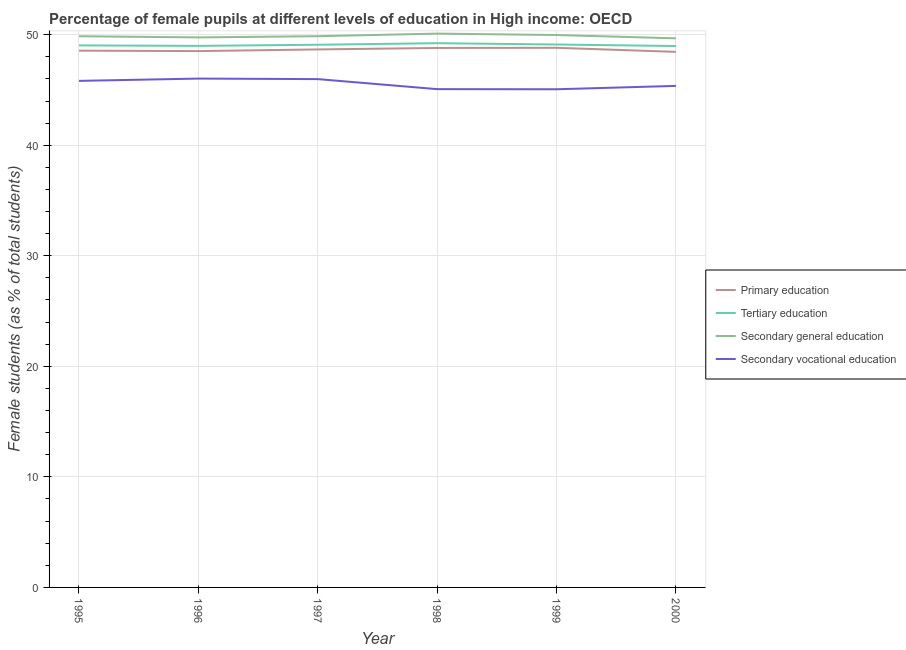How many different coloured lines are there?
Provide a succinct answer. 4. What is the percentage of female students in secondary vocational education in 1997?
Give a very brief answer. 45.98. Across all years, what is the maximum percentage of female students in secondary vocational education?
Provide a short and direct response. 46.03. Across all years, what is the minimum percentage of female students in tertiary education?
Your answer should be compact. 48.97. In which year was the percentage of female students in secondary education minimum?
Your answer should be very brief. 2000. What is the total percentage of female students in primary education in the graph?
Provide a short and direct response. 291.79. What is the difference between the percentage of female students in primary education in 1997 and that in 1999?
Your answer should be very brief. -0.15. What is the difference between the percentage of female students in secondary education in 2000 and the percentage of female students in primary education in 1999?
Ensure brevity in your answer.  0.86. What is the average percentage of female students in primary education per year?
Provide a short and direct response. 48.63. In the year 1995, what is the difference between the percentage of female students in primary education and percentage of female students in tertiary education?
Keep it short and to the point. -0.48. What is the ratio of the percentage of female students in primary education in 1998 to that in 2000?
Offer a very short reply. 1.01. Is the difference between the percentage of female students in tertiary education in 1996 and 1998 greater than the difference between the percentage of female students in secondary vocational education in 1996 and 1998?
Your answer should be very brief. No. What is the difference between the highest and the second highest percentage of female students in tertiary education?
Offer a very short reply. 0.12. What is the difference between the highest and the lowest percentage of female students in secondary vocational education?
Provide a succinct answer. 0.97. In how many years, is the percentage of female students in secondary vocational education greater than the average percentage of female students in secondary vocational education taken over all years?
Make the answer very short. 3. Is it the case that in every year, the sum of the percentage of female students in tertiary education and percentage of female students in primary education is greater than the sum of percentage of female students in secondary vocational education and percentage of female students in secondary education?
Offer a very short reply. Yes. Is it the case that in every year, the sum of the percentage of female students in primary education and percentage of female students in tertiary education is greater than the percentage of female students in secondary education?
Ensure brevity in your answer.  Yes. Is the percentage of female students in tertiary education strictly greater than the percentage of female students in secondary vocational education over the years?
Your answer should be very brief. Yes. Is the percentage of female students in secondary vocational education strictly less than the percentage of female students in primary education over the years?
Your response must be concise. Yes. How many lines are there?
Make the answer very short. 4. Does the graph contain any zero values?
Provide a succinct answer. No. Where does the legend appear in the graph?
Ensure brevity in your answer.  Center right. How many legend labels are there?
Offer a terse response. 4. What is the title of the graph?
Your response must be concise. Percentage of female pupils at different levels of education in High income: OECD. Does "Forest" appear as one of the legend labels in the graph?
Offer a very short reply. No. What is the label or title of the X-axis?
Make the answer very short. Year. What is the label or title of the Y-axis?
Your response must be concise. Female students (as % of total students). What is the Female students (as % of total students) of Primary education in 1995?
Ensure brevity in your answer.  48.55. What is the Female students (as % of total students) of Tertiary education in 1995?
Offer a terse response. 49.03. What is the Female students (as % of total students) of Secondary general education in 1995?
Give a very brief answer. 49.86. What is the Female students (as % of total students) of Secondary vocational education in 1995?
Ensure brevity in your answer.  45.82. What is the Female students (as % of total students) of Primary education in 1996?
Provide a succinct answer. 48.52. What is the Female students (as % of total students) of Tertiary education in 1996?
Provide a short and direct response. 48.99. What is the Female students (as % of total students) in Secondary general education in 1996?
Ensure brevity in your answer.  49.75. What is the Female students (as % of total students) of Secondary vocational education in 1996?
Ensure brevity in your answer.  46.03. What is the Female students (as % of total students) of Primary education in 1997?
Give a very brief answer. 48.67. What is the Female students (as % of total students) of Tertiary education in 1997?
Your answer should be very brief. 49.09. What is the Female students (as % of total students) of Secondary general education in 1997?
Offer a terse response. 49.86. What is the Female students (as % of total students) in Secondary vocational education in 1997?
Offer a terse response. 45.98. What is the Female students (as % of total students) of Primary education in 1998?
Keep it short and to the point. 48.8. What is the Female students (as % of total students) in Tertiary education in 1998?
Make the answer very short. 49.23. What is the Female students (as % of total students) of Secondary general education in 1998?
Offer a very short reply. 50.1. What is the Female students (as % of total students) of Secondary vocational education in 1998?
Ensure brevity in your answer.  45.07. What is the Female students (as % of total students) of Primary education in 1999?
Make the answer very short. 48.81. What is the Female students (as % of total students) of Tertiary education in 1999?
Offer a terse response. 49.11. What is the Female students (as % of total students) of Secondary general education in 1999?
Give a very brief answer. 49.97. What is the Female students (as % of total students) of Secondary vocational education in 1999?
Ensure brevity in your answer.  45.06. What is the Female students (as % of total students) in Primary education in 2000?
Give a very brief answer. 48.45. What is the Female students (as % of total students) of Tertiary education in 2000?
Make the answer very short. 48.97. What is the Female students (as % of total students) in Secondary general education in 2000?
Offer a terse response. 49.67. What is the Female students (as % of total students) of Secondary vocational education in 2000?
Keep it short and to the point. 45.37. Across all years, what is the maximum Female students (as % of total students) of Primary education?
Give a very brief answer. 48.81. Across all years, what is the maximum Female students (as % of total students) of Tertiary education?
Offer a very short reply. 49.23. Across all years, what is the maximum Female students (as % of total students) in Secondary general education?
Provide a short and direct response. 50.1. Across all years, what is the maximum Female students (as % of total students) in Secondary vocational education?
Keep it short and to the point. 46.03. Across all years, what is the minimum Female students (as % of total students) in Primary education?
Your answer should be compact. 48.45. Across all years, what is the minimum Female students (as % of total students) in Tertiary education?
Provide a short and direct response. 48.97. Across all years, what is the minimum Female students (as % of total students) of Secondary general education?
Keep it short and to the point. 49.67. Across all years, what is the minimum Female students (as % of total students) of Secondary vocational education?
Offer a very short reply. 45.06. What is the total Female students (as % of total students) in Primary education in the graph?
Ensure brevity in your answer.  291.79. What is the total Female students (as % of total students) in Tertiary education in the graph?
Provide a short and direct response. 294.42. What is the total Female students (as % of total students) in Secondary general education in the graph?
Ensure brevity in your answer.  299.21. What is the total Female students (as % of total students) in Secondary vocational education in the graph?
Keep it short and to the point. 273.33. What is the difference between the Female students (as % of total students) of Primary education in 1995 and that in 1996?
Ensure brevity in your answer.  0.04. What is the difference between the Female students (as % of total students) in Tertiary education in 1995 and that in 1996?
Offer a very short reply. 0.04. What is the difference between the Female students (as % of total students) in Secondary general education in 1995 and that in 1996?
Provide a succinct answer. 0.11. What is the difference between the Female students (as % of total students) of Secondary vocational education in 1995 and that in 1996?
Your answer should be compact. -0.21. What is the difference between the Female students (as % of total students) of Primary education in 1995 and that in 1997?
Offer a terse response. -0.11. What is the difference between the Female students (as % of total students) of Tertiary education in 1995 and that in 1997?
Keep it short and to the point. -0.06. What is the difference between the Female students (as % of total students) in Secondary general education in 1995 and that in 1997?
Make the answer very short. -0. What is the difference between the Female students (as % of total students) in Secondary vocational education in 1995 and that in 1997?
Provide a short and direct response. -0.16. What is the difference between the Female students (as % of total students) of Primary education in 1995 and that in 1998?
Provide a short and direct response. -0.24. What is the difference between the Female students (as % of total students) in Tertiary education in 1995 and that in 1998?
Your answer should be very brief. -0.2. What is the difference between the Female students (as % of total students) of Secondary general education in 1995 and that in 1998?
Ensure brevity in your answer.  -0.24. What is the difference between the Female students (as % of total students) of Secondary vocational education in 1995 and that in 1998?
Provide a succinct answer. 0.75. What is the difference between the Female students (as % of total students) of Primary education in 1995 and that in 1999?
Provide a succinct answer. -0.26. What is the difference between the Female students (as % of total students) in Tertiary education in 1995 and that in 1999?
Make the answer very short. -0.08. What is the difference between the Female students (as % of total students) in Secondary general education in 1995 and that in 1999?
Offer a terse response. -0.11. What is the difference between the Female students (as % of total students) of Secondary vocational education in 1995 and that in 1999?
Give a very brief answer. 0.76. What is the difference between the Female students (as % of total students) in Primary education in 1995 and that in 2000?
Your answer should be compact. 0.11. What is the difference between the Female students (as % of total students) in Tertiary education in 1995 and that in 2000?
Your answer should be very brief. 0.06. What is the difference between the Female students (as % of total students) in Secondary general education in 1995 and that in 2000?
Offer a terse response. 0.19. What is the difference between the Female students (as % of total students) in Secondary vocational education in 1995 and that in 2000?
Keep it short and to the point. 0.45. What is the difference between the Female students (as % of total students) of Primary education in 1996 and that in 1997?
Provide a short and direct response. -0.15. What is the difference between the Female students (as % of total students) of Tertiary education in 1996 and that in 1997?
Your answer should be compact. -0.1. What is the difference between the Female students (as % of total students) in Secondary general education in 1996 and that in 1997?
Give a very brief answer. -0.11. What is the difference between the Female students (as % of total students) of Secondary vocational education in 1996 and that in 1997?
Your response must be concise. 0.05. What is the difference between the Female students (as % of total students) of Primary education in 1996 and that in 1998?
Your answer should be very brief. -0.28. What is the difference between the Female students (as % of total students) in Tertiary education in 1996 and that in 1998?
Your answer should be compact. -0.24. What is the difference between the Female students (as % of total students) of Secondary general education in 1996 and that in 1998?
Offer a very short reply. -0.34. What is the difference between the Female students (as % of total students) in Secondary vocational education in 1996 and that in 1998?
Provide a succinct answer. 0.96. What is the difference between the Female students (as % of total students) in Primary education in 1996 and that in 1999?
Make the answer very short. -0.3. What is the difference between the Female students (as % of total students) in Tertiary education in 1996 and that in 1999?
Your answer should be compact. -0.12. What is the difference between the Female students (as % of total students) of Secondary general education in 1996 and that in 1999?
Ensure brevity in your answer.  -0.22. What is the difference between the Female students (as % of total students) of Secondary vocational education in 1996 and that in 1999?
Provide a short and direct response. 0.97. What is the difference between the Female students (as % of total students) in Primary education in 1996 and that in 2000?
Provide a succinct answer. 0.07. What is the difference between the Female students (as % of total students) in Tertiary education in 1996 and that in 2000?
Your answer should be compact. 0.01. What is the difference between the Female students (as % of total students) in Secondary general education in 1996 and that in 2000?
Provide a short and direct response. 0.08. What is the difference between the Female students (as % of total students) of Secondary vocational education in 1996 and that in 2000?
Give a very brief answer. 0.66. What is the difference between the Female students (as % of total students) of Primary education in 1997 and that in 1998?
Provide a short and direct response. -0.13. What is the difference between the Female students (as % of total students) of Tertiary education in 1997 and that in 1998?
Your answer should be very brief. -0.14. What is the difference between the Female students (as % of total students) of Secondary general education in 1997 and that in 1998?
Your answer should be very brief. -0.24. What is the difference between the Female students (as % of total students) of Secondary vocational education in 1997 and that in 1998?
Make the answer very short. 0.91. What is the difference between the Female students (as % of total students) in Primary education in 1997 and that in 1999?
Offer a terse response. -0.15. What is the difference between the Female students (as % of total students) in Tertiary education in 1997 and that in 1999?
Provide a short and direct response. -0.02. What is the difference between the Female students (as % of total students) in Secondary general education in 1997 and that in 1999?
Offer a terse response. -0.11. What is the difference between the Female students (as % of total students) of Secondary vocational education in 1997 and that in 1999?
Your answer should be compact. 0.92. What is the difference between the Female students (as % of total students) of Primary education in 1997 and that in 2000?
Provide a succinct answer. 0.22. What is the difference between the Female students (as % of total students) of Tertiary education in 1997 and that in 2000?
Provide a short and direct response. 0.12. What is the difference between the Female students (as % of total students) in Secondary general education in 1997 and that in 2000?
Your response must be concise. 0.19. What is the difference between the Female students (as % of total students) of Secondary vocational education in 1997 and that in 2000?
Give a very brief answer. 0.61. What is the difference between the Female students (as % of total students) of Primary education in 1998 and that in 1999?
Offer a terse response. -0.01. What is the difference between the Female students (as % of total students) in Tertiary education in 1998 and that in 1999?
Your response must be concise. 0.12. What is the difference between the Female students (as % of total students) of Secondary general education in 1998 and that in 1999?
Your answer should be compact. 0.13. What is the difference between the Female students (as % of total students) of Secondary vocational education in 1998 and that in 1999?
Offer a terse response. 0.01. What is the difference between the Female students (as % of total students) of Primary education in 1998 and that in 2000?
Keep it short and to the point. 0.35. What is the difference between the Female students (as % of total students) of Tertiary education in 1998 and that in 2000?
Give a very brief answer. 0.26. What is the difference between the Female students (as % of total students) in Secondary general education in 1998 and that in 2000?
Keep it short and to the point. 0.43. What is the difference between the Female students (as % of total students) in Secondary vocational education in 1998 and that in 2000?
Keep it short and to the point. -0.29. What is the difference between the Female students (as % of total students) in Primary education in 1999 and that in 2000?
Make the answer very short. 0.37. What is the difference between the Female students (as % of total students) in Tertiary education in 1999 and that in 2000?
Make the answer very short. 0.14. What is the difference between the Female students (as % of total students) of Secondary general education in 1999 and that in 2000?
Provide a succinct answer. 0.3. What is the difference between the Female students (as % of total students) of Secondary vocational education in 1999 and that in 2000?
Your answer should be very brief. -0.31. What is the difference between the Female students (as % of total students) of Primary education in 1995 and the Female students (as % of total students) of Tertiary education in 1996?
Give a very brief answer. -0.43. What is the difference between the Female students (as % of total students) in Primary education in 1995 and the Female students (as % of total students) in Secondary general education in 1996?
Your answer should be very brief. -1.2. What is the difference between the Female students (as % of total students) in Primary education in 1995 and the Female students (as % of total students) in Secondary vocational education in 1996?
Make the answer very short. 2.52. What is the difference between the Female students (as % of total students) of Tertiary education in 1995 and the Female students (as % of total students) of Secondary general education in 1996?
Keep it short and to the point. -0.72. What is the difference between the Female students (as % of total students) in Tertiary education in 1995 and the Female students (as % of total students) in Secondary vocational education in 1996?
Ensure brevity in your answer.  3. What is the difference between the Female students (as % of total students) in Secondary general education in 1995 and the Female students (as % of total students) in Secondary vocational education in 1996?
Your answer should be very brief. 3.83. What is the difference between the Female students (as % of total students) of Primary education in 1995 and the Female students (as % of total students) of Tertiary education in 1997?
Your answer should be compact. -0.54. What is the difference between the Female students (as % of total students) of Primary education in 1995 and the Female students (as % of total students) of Secondary general education in 1997?
Offer a very short reply. -1.31. What is the difference between the Female students (as % of total students) of Primary education in 1995 and the Female students (as % of total students) of Secondary vocational education in 1997?
Provide a short and direct response. 2.57. What is the difference between the Female students (as % of total students) of Tertiary education in 1995 and the Female students (as % of total students) of Secondary general education in 1997?
Your response must be concise. -0.83. What is the difference between the Female students (as % of total students) in Tertiary education in 1995 and the Female students (as % of total students) in Secondary vocational education in 1997?
Your response must be concise. 3.05. What is the difference between the Female students (as % of total students) of Secondary general education in 1995 and the Female students (as % of total students) of Secondary vocational education in 1997?
Ensure brevity in your answer.  3.88. What is the difference between the Female students (as % of total students) in Primary education in 1995 and the Female students (as % of total students) in Tertiary education in 1998?
Your answer should be compact. -0.68. What is the difference between the Female students (as % of total students) in Primary education in 1995 and the Female students (as % of total students) in Secondary general education in 1998?
Offer a very short reply. -1.54. What is the difference between the Female students (as % of total students) of Primary education in 1995 and the Female students (as % of total students) of Secondary vocational education in 1998?
Provide a succinct answer. 3.48. What is the difference between the Female students (as % of total students) of Tertiary education in 1995 and the Female students (as % of total students) of Secondary general education in 1998?
Your answer should be very brief. -1.07. What is the difference between the Female students (as % of total students) in Tertiary education in 1995 and the Female students (as % of total students) in Secondary vocational education in 1998?
Give a very brief answer. 3.96. What is the difference between the Female students (as % of total students) of Secondary general education in 1995 and the Female students (as % of total students) of Secondary vocational education in 1998?
Your answer should be compact. 4.78. What is the difference between the Female students (as % of total students) of Primary education in 1995 and the Female students (as % of total students) of Tertiary education in 1999?
Ensure brevity in your answer.  -0.56. What is the difference between the Female students (as % of total students) of Primary education in 1995 and the Female students (as % of total students) of Secondary general education in 1999?
Ensure brevity in your answer.  -1.41. What is the difference between the Female students (as % of total students) in Primary education in 1995 and the Female students (as % of total students) in Secondary vocational education in 1999?
Make the answer very short. 3.49. What is the difference between the Female students (as % of total students) of Tertiary education in 1995 and the Female students (as % of total students) of Secondary general education in 1999?
Keep it short and to the point. -0.94. What is the difference between the Female students (as % of total students) of Tertiary education in 1995 and the Female students (as % of total students) of Secondary vocational education in 1999?
Make the answer very short. 3.97. What is the difference between the Female students (as % of total students) of Secondary general education in 1995 and the Female students (as % of total students) of Secondary vocational education in 1999?
Keep it short and to the point. 4.8. What is the difference between the Female students (as % of total students) in Primary education in 1995 and the Female students (as % of total students) in Tertiary education in 2000?
Your answer should be compact. -0.42. What is the difference between the Female students (as % of total students) of Primary education in 1995 and the Female students (as % of total students) of Secondary general education in 2000?
Ensure brevity in your answer.  -1.12. What is the difference between the Female students (as % of total students) of Primary education in 1995 and the Female students (as % of total students) of Secondary vocational education in 2000?
Provide a short and direct response. 3.19. What is the difference between the Female students (as % of total students) in Tertiary education in 1995 and the Female students (as % of total students) in Secondary general education in 2000?
Give a very brief answer. -0.64. What is the difference between the Female students (as % of total students) in Tertiary education in 1995 and the Female students (as % of total students) in Secondary vocational education in 2000?
Keep it short and to the point. 3.66. What is the difference between the Female students (as % of total students) of Secondary general education in 1995 and the Female students (as % of total students) of Secondary vocational education in 2000?
Provide a succinct answer. 4.49. What is the difference between the Female students (as % of total students) in Primary education in 1996 and the Female students (as % of total students) in Tertiary education in 1997?
Provide a short and direct response. -0.58. What is the difference between the Female students (as % of total students) of Primary education in 1996 and the Female students (as % of total students) of Secondary general education in 1997?
Provide a succinct answer. -1.35. What is the difference between the Female students (as % of total students) in Primary education in 1996 and the Female students (as % of total students) in Secondary vocational education in 1997?
Offer a terse response. 2.53. What is the difference between the Female students (as % of total students) of Tertiary education in 1996 and the Female students (as % of total students) of Secondary general education in 1997?
Offer a terse response. -0.87. What is the difference between the Female students (as % of total students) in Tertiary education in 1996 and the Female students (as % of total students) in Secondary vocational education in 1997?
Keep it short and to the point. 3.01. What is the difference between the Female students (as % of total students) of Secondary general education in 1996 and the Female students (as % of total students) of Secondary vocational education in 1997?
Ensure brevity in your answer.  3.77. What is the difference between the Female students (as % of total students) in Primary education in 1996 and the Female students (as % of total students) in Tertiary education in 1998?
Your answer should be very brief. -0.71. What is the difference between the Female students (as % of total students) of Primary education in 1996 and the Female students (as % of total students) of Secondary general education in 1998?
Give a very brief answer. -1.58. What is the difference between the Female students (as % of total students) in Primary education in 1996 and the Female students (as % of total students) in Secondary vocational education in 1998?
Keep it short and to the point. 3.44. What is the difference between the Female students (as % of total students) of Tertiary education in 1996 and the Female students (as % of total students) of Secondary general education in 1998?
Ensure brevity in your answer.  -1.11. What is the difference between the Female students (as % of total students) of Tertiary education in 1996 and the Female students (as % of total students) of Secondary vocational education in 1998?
Your answer should be very brief. 3.91. What is the difference between the Female students (as % of total students) of Secondary general education in 1996 and the Female students (as % of total students) of Secondary vocational education in 1998?
Provide a succinct answer. 4.68. What is the difference between the Female students (as % of total students) in Primary education in 1996 and the Female students (as % of total students) in Tertiary education in 1999?
Your response must be concise. -0.6. What is the difference between the Female students (as % of total students) of Primary education in 1996 and the Female students (as % of total students) of Secondary general education in 1999?
Provide a succinct answer. -1.45. What is the difference between the Female students (as % of total students) in Primary education in 1996 and the Female students (as % of total students) in Secondary vocational education in 1999?
Ensure brevity in your answer.  3.45. What is the difference between the Female students (as % of total students) in Tertiary education in 1996 and the Female students (as % of total students) in Secondary general education in 1999?
Ensure brevity in your answer.  -0.98. What is the difference between the Female students (as % of total students) of Tertiary education in 1996 and the Female students (as % of total students) of Secondary vocational education in 1999?
Your answer should be compact. 3.93. What is the difference between the Female students (as % of total students) of Secondary general education in 1996 and the Female students (as % of total students) of Secondary vocational education in 1999?
Your answer should be compact. 4.69. What is the difference between the Female students (as % of total students) of Primary education in 1996 and the Female students (as % of total students) of Tertiary education in 2000?
Offer a very short reply. -0.46. What is the difference between the Female students (as % of total students) in Primary education in 1996 and the Female students (as % of total students) in Secondary general education in 2000?
Your response must be concise. -1.16. What is the difference between the Female students (as % of total students) of Primary education in 1996 and the Female students (as % of total students) of Secondary vocational education in 2000?
Your answer should be compact. 3.15. What is the difference between the Female students (as % of total students) in Tertiary education in 1996 and the Female students (as % of total students) in Secondary general education in 2000?
Give a very brief answer. -0.68. What is the difference between the Female students (as % of total students) of Tertiary education in 1996 and the Female students (as % of total students) of Secondary vocational education in 2000?
Your answer should be compact. 3.62. What is the difference between the Female students (as % of total students) of Secondary general education in 1996 and the Female students (as % of total students) of Secondary vocational education in 2000?
Your answer should be very brief. 4.39. What is the difference between the Female students (as % of total students) of Primary education in 1997 and the Female students (as % of total students) of Tertiary education in 1998?
Provide a short and direct response. -0.56. What is the difference between the Female students (as % of total students) in Primary education in 1997 and the Female students (as % of total students) in Secondary general education in 1998?
Provide a short and direct response. -1.43. What is the difference between the Female students (as % of total students) in Primary education in 1997 and the Female students (as % of total students) in Secondary vocational education in 1998?
Make the answer very short. 3.59. What is the difference between the Female students (as % of total students) in Tertiary education in 1997 and the Female students (as % of total students) in Secondary general education in 1998?
Provide a succinct answer. -1.01. What is the difference between the Female students (as % of total students) in Tertiary education in 1997 and the Female students (as % of total students) in Secondary vocational education in 1998?
Your answer should be compact. 4.02. What is the difference between the Female students (as % of total students) of Secondary general education in 1997 and the Female students (as % of total students) of Secondary vocational education in 1998?
Your answer should be compact. 4.79. What is the difference between the Female students (as % of total students) in Primary education in 1997 and the Female students (as % of total students) in Tertiary education in 1999?
Ensure brevity in your answer.  -0.45. What is the difference between the Female students (as % of total students) in Primary education in 1997 and the Female students (as % of total students) in Secondary general education in 1999?
Offer a very short reply. -1.3. What is the difference between the Female students (as % of total students) in Primary education in 1997 and the Female students (as % of total students) in Secondary vocational education in 1999?
Your answer should be very brief. 3.6. What is the difference between the Female students (as % of total students) in Tertiary education in 1997 and the Female students (as % of total students) in Secondary general education in 1999?
Provide a succinct answer. -0.88. What is the difference between the Female students (as % of total students) in Tertiary education in 1997 and the Female students (as % of total students) in Secondary vocational education in 1999?
Make the answer very short. 4.03. What is the difference between the Female students (as % of total students) of Secondary general education in 1997 and the Female students (as % of total students) of Secondary vocational education in 1999?
Keep it short and to the point. 4.8. What is the difference between the Female students (as % of total students) in Primary education in 1997 and the Female students (as % of total students) in Tertiary education in 2000?
Provide a succinct answer. -0.31. What is the difference between the Female students (as % of total students) of Primary education in 1997 and the Female students (as % of total students) of Secondary general education in 2000?
Provide a short and direct response. -1.01. What is the difference between the Female students (as % of total students) of Primary education in 1997 and the Female students (as % of total students) of Secondary vocational education in 2000?
Your answer should be very brief. 3.3. What is the difference between the Female students (as % of total students) of Tertiary education in 1997 and the Female students (as % of total students) of Secondary general education in 2000?
Provide a short and direct response. -0.58. What is the difference between the Female students (as % of total students) of Tertiary education in 1997 and the Female students (as % of total students) of Secondary vocational education in 2000?
Ensure brevity in your answer.  3.72. What is the difference between the Female students (as % of total students) of Secondary general education in 1997 and the Female students (as % of total students) of Secondary vocational education in 2000?
Your response must be concise. 4.49. What is the difference between the Female students (as % of total students) in Primary education in 1998 and the Female students (as % of total students) in Tertiary education in 1999?
Give a very brief answer. -0.31. What is the difference between the Female students (as % of total students) of Primary education in 1998 and the Female students (as % of total students) of Secondary general education in 1999?
Your answer should be compact. -1.17. What is the difference between the Female students (as % of total students) of Primary education in 1998 and the Female students (as % of total students) of Secondary vocational education in 1999?
Keep it short and to the point. 3.74. What is the difference between the Female students (as % of total students) of Tertiary education in 1998 and the Female students (as % of total students) of Secondary general education in 1999?
Offer a very short reply. -0.74. What is the difference between the Female students (as % of total students) of Tertiary education in 1998 and the Female students (as % of total students) of Secondary vocational education in 1999?
Your response must be concise. 4.17. What is the difference between the Female students (as % of total students) in Secondary general education in 1998 and the Female students (as % of total students) in Secondary vocational education in 1999?
Offer a very short reply. 5.04. What is the difference between the Female students (as % of total students) of Primary education in 1998 and the Female students (as % of total students) of Tertiary education in 2000?
Your answer should be compact. -0.17. What is the difference between the Female students (as % of total students) of Primary education in 1998 and the Female students (as % of total students) of Secondary general education in 2000?
Your answer should be compact. -0.87. What is the difference between the Female students (as % of total students) of Primary education in 1998 and the Female students (as % of total students) of Secondary vocational education in 2000?
Keep it short and to the point. 3.43. What is the difference between the Female students (as % of total students) in Tertiary education in 1998 and the Female students (as % of total students) in Secondary general education in 2000?
Provide a succinct answer. -0.44. What is the difference between the Female students (as % of total students) of Tertiary education in 1998 and the Female students (as % of total students) of Secondary vocational education in 2000?
Offer a terse response. 3.86. What is the difference between the Female students (as % of total students) in Secondary general education in 1998 and the Female students (as % of total students) in Secondary vocational education in 2000?
Make the answer very short. 4.73. What is the difference between the Female students (as % of total students) in Primary education in 1999 and the Female students (as % of total students) in Tertiary education in 2000?
Provide a succinct answer. -0.16. What is the difference between the Female students (as % of total students) of Primary education in 1999 and the Female students (as % of total students) of Secondary general education in 2000?
Your response must be concise. -0.86. What is the difference between the Female students (as % of total students) in Primary education in 1999 and the Female students (as % of total students) in Secondary vocational education in 2000?
Ensure brevity in your answer.  3.44. What is the difference between the Female students (as % of total students) of Tertiary education in 1999 and the Female students (as % of total students) of Secondary general education in 2000?
Provide a short and direct response. -0.56. What is the difference between the Female students (as % of total students) in Tertiary education in 1999 and the Female students (as % of total students) in Secondary vocational education in 2000?
Offer a terse response. 3.74. What is the difference between the Female students (as % of total students) in Secondary general education in 1999 and the Female students (as % of total students) in Secondary vocational education in 2000?
Make the answer very short. 4.6. What is the average Female students (as % of total students) in Primary education per year?
Make the answer very short. 48.63. What is the average Female students (as % of total students) of Tertiary education per year?
Provide a succinct answer. 49.07. What is the average Female students (as % of total students) of Secondary general education per year?
Ensure brevity in your answer.  49.87. What is the average Female students (as % of total students) in Secondary vocational education per year?
Provide a short and direct response. 45.56. In the year 1995, what is the difference between the Female students (as % of total students) in Primary education and Female students (as % of total students) in Tertiary education?
Keep it short and to the point. -0.48. In the year 1995, what is the difference between the Female students (as % of total students) in Primary education and Female students (as % of total students) in Secondary general education?
Your answer should be compact. -1.3. In the year 1995, what is the difference between the Female students (as % of total students) of Primary education and Female students (as % of total students) of Secondary vocational education?
Your answer should be compact. 2.73. In the year 1995, what is the difference between the Female students (as % of total students) in Tertiary education and Female students (as % of total students) in Secondary general education?
Offer a very short reply. -0.83. In the year 1995, what is the difference between the Female students (as % of total students) of Tertiary education and Female students (as % of total students) of Secondary vocational education?
Your answer should be compact. 3.21. In the year 1995, what is the difference between the Female students (as % of total students) of Secondary general education and Female students (as % of total students) of Secondary vocational education?
Make the answer very short. 4.04. In the year 1996, what is the difference between the Female students (as % of total students) of Primary education and Female students (as % of total students) of Tertiary education?
Offer a very short reply. -0.47. In the year 1996, what is the difference between the Female students (as % of total students) in Primary education and Female students (as % of total students) in Secondary general education?
Provide a short and direct response. -1.24. In the year 1996, what is the difference between the Female students (as % of total students) of Primary education and Female students (as % of total students) of Secondary vocational education?
Provide a short and direct response. 2.49. In the year 1996, what is the difference between the Female students (as % of total students) of Tertiary education and Female students (as % of total students) of Secondary general education?
Your answer should be compact. -0.77. In the year 1996, what is the difference between the Female students (as % of total students) in Tertiary education and Female students (as % of total students) in Secondary vocational education?
Your answer should be compact. 2.96. In the year 1996, what is the difference between the Female students (as % of total students) in Secondary general education and Female students (as % of total students) in Secondary vocational education?
Ensure brevity in your answer.  3.72. In the year 1997, what is the difference between the Female students (as % of total students) in Primary education and Female students (as % of total students) in Tertiary education?
Your response must be concise. -0.43. In the year 1997, what is the difference between the Female students (as % of total students) in Primary education and Female students (as % of total students) in Secondary general education?
Give a very brief answer. -1.2. In the year 1997, what is the difference between the Female students (as % of total students) in Primary education and Female students (as % of total students) in Secondary vocational education?
Your response must be concise. 2.68. In the year 1997, what is the difference between the Female students (as % of total students) in Tertiary education and Female students (as % of total students) in Secondary general education?
Provide a succinct answer. -0.77. In the year 1997, what is the difference between the Female students (as % of total students) in Tertiary education and Female students (as % of total students) in Secondary vocational education?
Ensure brevity in your answer.  3.11. In the year 1997, what is the difference between the Female students (as % of total students) in Secondary general education and Female students (as % of total students) in Secondary vocational education?
Give a very brief answer. 3.88. In the year 1998, what is the difference between the Female students (as % of total students) in Primary education and Female students (as % of total students) in Tertiary education?
Keep it short and to the point. -0.43. In the year 1998, what is the difference between the Female students (as % of total students) in Primary education and Female students (as % of total students) in Secondary general education?
Keep it short and to the point. -1.3. In the year 1998, what is the difference between the Female students (as % of total students) in Primary education and Female students (as % of total students) in Secondary vocational education?
Offer a very short reply. 3.73. In the year 1998, what is the difference between the Female students (as % of total students) in Tertiary education and Female students (as % of total students) in Secondary general education?
Your answer should be very brief. -0.87. In the year 1998, what is the difference between the Female students (as % of total students) of Tertiary education and Female students (as % of total students) of Secondary vocational education?
Keep it short and to the point. 4.16. In the year 1998, what is the difference between the Female students (as % of total students) in Secondary general education and Female students (as % of total students) in Secondary vocational education?
Make the answer very short. 5.02. In the year 1999, what is the difference between the Female students (as % of total students) in Primary education and Female students (as % of total students) in Tertiary education?
Your response must be concise. -0.3. In the year 1999, what is the difference between the Female students (as % of total students) in Primary education and Female students (as % of total students) in Secondary general education?
Offer a very short reply. -1.16. In the year 1999, what is the difference between the Female students (as % of total students) in Primary education and Female students (as % of total students) in Secondary vocational education?
Your answer should be very brief. 3.75. In the year 1999, what is the difference between the Female students (as % of total students) of Tertiary education and Female students (as % of total students) of Secondary general education?
Provide a short and direct response. -0.86. In the year 1999, what is the difference between the Female students (as % of total students) in Tertiary education and Female students (as % of total students) in Secondary vocational education?
Give a very brief answer. 4.05. In the year 1999, what is the difference between the Female students (as % of total students) in Secondary general education and Female students (as % of total students) in Secondary vocational education?
Your answer should be compact. 4.91. In the year 2000, what is the difference between the Female students (as % of total students) of Primary education and Female students (as % of total students) of Tertiary education?
Your response must be concise. -0.53. In the year 2000, what is the difference between the Female students (as % of total students) of Primary education and Female students (as % of total students) of Secondary general education?
Provide a succinct answer. -1.22. In the year 2000, what is the difference between the Female students (as % of total students) of Primary education and Female students (as % of total students) of Secondary vocational education?
Your response must be concise. 3.08. In the year 2000, what is the difference between the Female students (as % of total students) in Tertiary education and Female students (as % of total students) in Secondary general education?
Give a very brief answer. -0.7. In the year 2000, what is the difference between the Female students (as % of total students) in Tertiary education and Female students (as % of total students) in Secondary vocational education?
Your answer should be compact. 3.61. In the year 2000, what is the difference between the Female students (as % of total students) in Secondary general education and Female students (as % of total students) in Secondary vocational education?
Provide a succinct answer. 4.3. What is the ratio of the Female students (as % of total students) of Secondary general education in 1995 to that in 1996?
Your response must be concise. 1. What is the ratio of the Female students (as % of total students) in Primary education in 1995 to that in 1997?
Ensure brevity in your answer.  1. What is the ratio of the Female students (as % of total students) in Tertiary education in 1995 to that in 1997?
Ensure brevity in your answer.  1. What is the ratio of the Female students (as % of total students) of Secondary general education in 1995 to that in 1997?
Offer a terse response. 1. What is the ratio of the Female students (as % of total students) of Secondary vocational education in 1995 to that in 1997?
Give a very brief answer. 1. What is the ratio of the Female students (as % of total students) of Primary education in 1995 to that in 1998?
Keep it short and to the point. 0.99. What is the ratio of the Female students (as % of total students) of Tertiary education in 1995 to that in 1998?
Make the answer very short. 1. What is the ratio of the Female students (as % of total students) in Secondary vocational education in 1995 to that in 1998?
Your answer should be very brief. 1.02. What is the ratio of the Female students (as % of total students) in Primary education in 1995 to that in 1999?
Ensure brevity in your answer.  0.99. What is the ratio of the Female students (as % of total students) of Secondary vocational education in 1995 to that in 1999?
Ensure brevity in your answer.  1.02. What is the ratio of the Female students (as % of total students) in Primary education in 1995 to that in 2000?
Your answer should be compact. 1. What is the ratio of the Female students (as % of total students) in Tertiary education in 1995 to that in 2000?
Keep it short and to the point. 1. What is the ratio of the Female students (as % of total students) of Secondary general education in 1995 to that in 2000?
Provide a short and direct response. 1. What is the ratio of the Female students (as % of total students) of Secondary vocational education in 1996 to that in 1997?
Give a very brief answer. 1. What is the ratio of the Female students (as % of total students) in Primary education in 1996 to that in 1998?
Your answer should be very brief. 0.99. What is the ratio of the Female students (as % of total students) in Tertiary education in 1996 to that in 1998?
Offer a terse response. 1. What is the ratio of the Female students (as % of total students) of Secondary general education in 1996 to that in 1998?
Your response must be concise. 0.99. What is the ratio of the Female students (as % of total students) in Secondary vocational education in 1996 to that in 1998?
Provide a succinct answer. 1.02. What is the ratio of the Female students (as % of total students) in Primary education in 1996 to that in 1999?
Your answer should be very brief. 0.99. What is the ratio of the Female students (as % of total students) in Tertiary education in 1996 to that in 1999?
Offer a terse response. 1. What is the ratio of the Female students (as % of total students) in Secondary general education in 1996 to that in 1999?
Offer a very short reply. 1. What is the ratio of the Female students (as % of total students) in Secondary vocational education in 1996 to that in 1999?
Your answer should be compact. 1.02. What is the ratio of the Female students (as % of total students) of Primary education in 1996 to that in 2000?
Keep it short and to the point. 1. What is the ratio of the Female students (as % of total students) in Tertiary education in 1996 to that in 2000?
Make the answer very short. 1. What is the ratio of the Female students (as % of total students) of Secondary vocational education in 1996 to that in 2000?
Your answer should be compact. 1.01. What is the ratio of the Female students (as % of total students) of Primary education in 1997 to that in 1998?
Ensure brevity in your answer.  1. What is the ratio of the Female students (as % of total students) of Secondary vocational education in 1997 to that in 1998?
Ensure brevity in your answer.  1.02. What is the ratio of the Female students (as % of total students) in Primary education in 1997 to that in 1999?
Make the answer very short. 1. What is the ratio of the Female students (as % of total students) of Secondary vocational education in 1997 to that in 1999?
Offer a terse response. 1.02. What is the ratio of the Female students (as % of total students) in Primary education in 1997 to that in 2000?
Ensure brevity in your answer.  1. What is the ratio of the Female students (as % of total students) in Tertiary education in 1997 to that in 2000?
Your answer should be compact. 1. What is the ratio of the Female students (as % of total students) of Secondary general education in 1997 to that in 2000?
Offer a very short reply. 1. What is the ratio of the Female students (as % of total students) in Secondary vocational education in 1997 to that in 2000?
Make the answer very short. 1.01. What is the ratio of the Female students (as % of total students) of Secondary vocational education in 1998 to that in 1999?
Your answer should be very brief. 1. What is the ratio of the Female students (as % of total students) in Primary education in 1998 to that in 2000?
Your answer should be very brief. 1.01. What is the ratio of the Female students (as % of total students) of Tertiary education in 1998 to that in 2000?
Provide a succinct answer. 1.01. What is the ratio of the Female students (as % of total students) in Secondary general education in 1998 to that in 2000?
Provide a short and direct response. 1.01. What is the ratio of the Female students (as % of total students) in Primary education in 1999 to that in 2000?
Keep it short and to the point. 1.01. What is the ratio of the Female students (as % of total students) of Tertiary education in 1999 to that in 2000?
Your response must be concise. 1. What is the ratio of the Female students (as % of total students) of Secondary vocational education in 1999 to that in 2000?
Your answer should be compact. 0.99. What is the difference between the highest and the second highest Female students (as % of total students) of Primary education?
Your response must be concise. 0.01. What is the difference between the highest and the second highest Female students (as % of total students) in Tertiary education?
Keep it short and to the point. 0.12. What is the difference between the highest and the second highest Female students (as % of total students) of Secondary general education?
Keep it short and to the point. 0.13. What is the difference between the highest and the second highest Female students (as % of total students) in Secondary vocational education?
Your response must be concise. 0.05. What is the difference between the highest and the lowest Female students (as % of total students) of Primary education?
Offer a terse response. 0.37. What is the difference between the highest and the lowest Female students (as % of total students) of Tertiary education?
Your response must be concise. 0.26. What is the difference between the highest and the lowest Female students (as % of total students) of Secondary general education?
Keep it short and to the point. 0.43. What is the difference between the highest and the lowest Female students (as % of total students) in Secondary vocational education?
Make the answer very short. 0.97. 